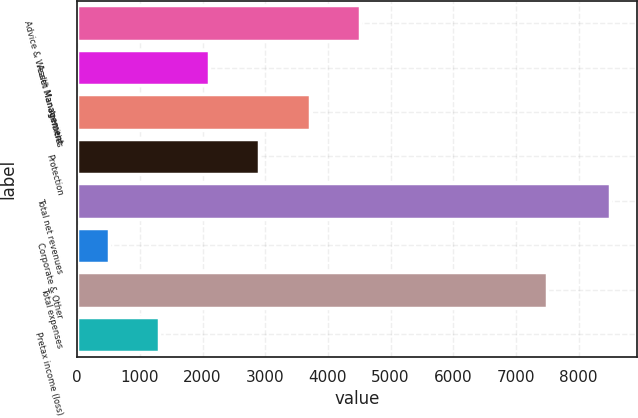Convert chart. <chart><loc_0><loc_0><loc_500><loc_500><bar_chart><fcel>Advice & Wealth Management<fcel>Asset Management<fcel>Annuities<fcel>Protection<fcel>Total net revenues<fcel>Corporate & Other<fcel>Total expenses<fcel>Pretax income (loss)<nl><fcel>4507<fcel>2107.6<fcel>3707.2<fcel>2907.4<fcel>8506<fcel>508<fcel>7498<fcel>1307.8<nl></chart> 